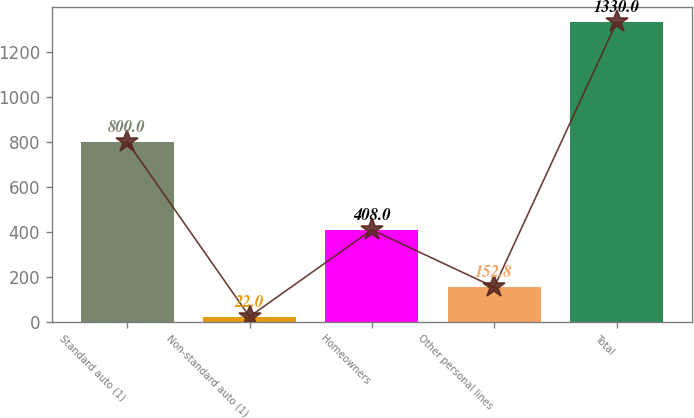Convert chart. <chart><loc_0><loc_0><loc_500><loc_500><bar_chart><fcel>Standard auto (1)<fcel>Non-standard auto (1)<fcel>Homeowners<fcel>Other personal lines<fcel>Total<nl><fcel>800<fcel>22<fcel>408<fcel>152.8<fcel>1330<nl></chart> 